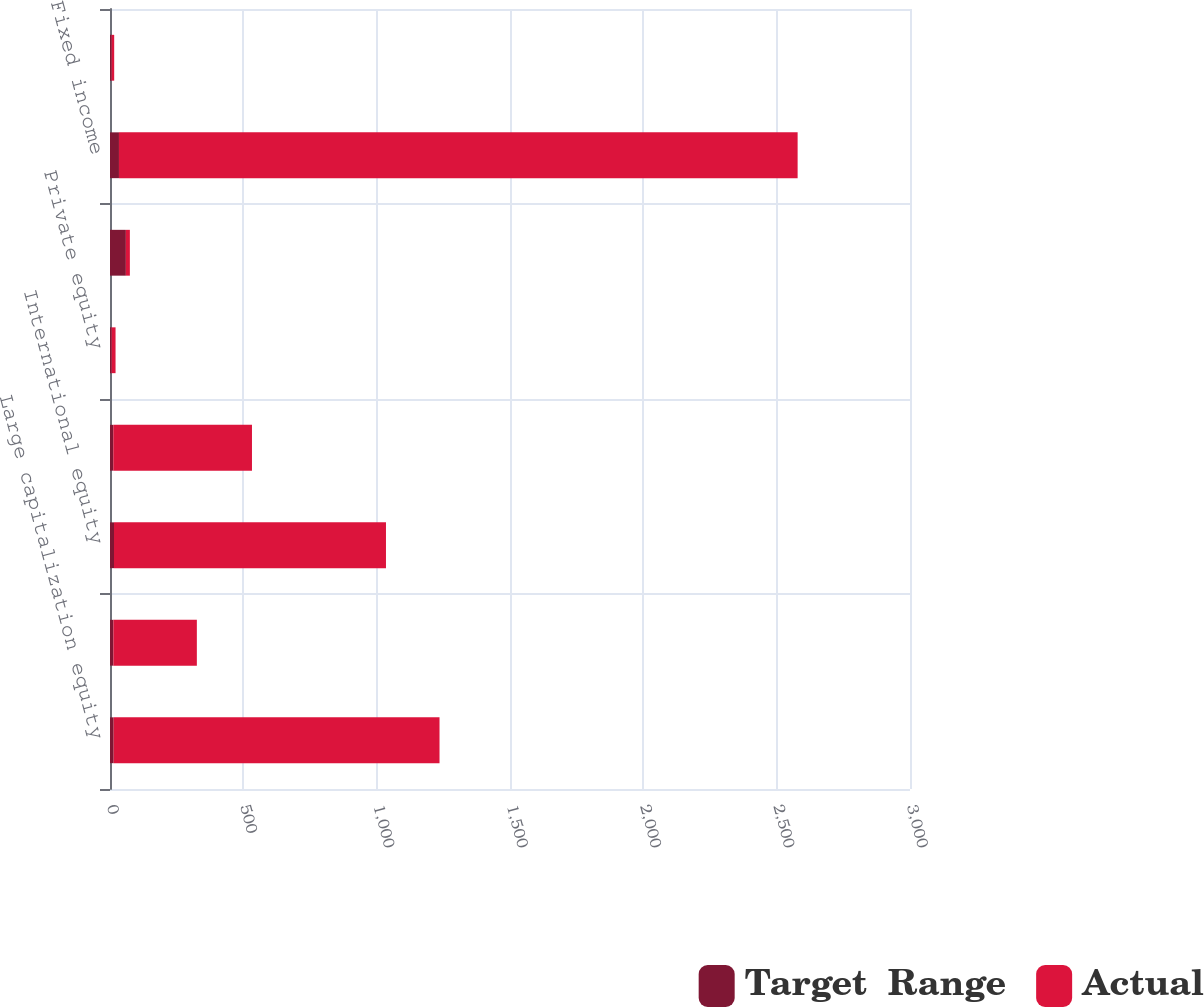<chart> <loc_0><loc_0><loc_500><loc_500><stacked_bar_chart><ecel><fcel>Large capitalization equity<fcel>Small capitalization equity<fcel>International equity<fcel>Global equity<fcel>Private equity<fcel>Total equity securities<fcel>Fixed income<fcel>Real estate<nl><fcel>Target  Range<fcel>13.7<fcel>12.7<fcel>14.9<fcel>12.4<fcel>5.8<fcel>59.5<fcel>33.6<fcel>5.7<nl><fcel>Actual<fcel>1222<fcel>313<fcel>1020<fcel>520<fcel>15<fcel>15<fcel>2545<fcel>10<nl></chart> 